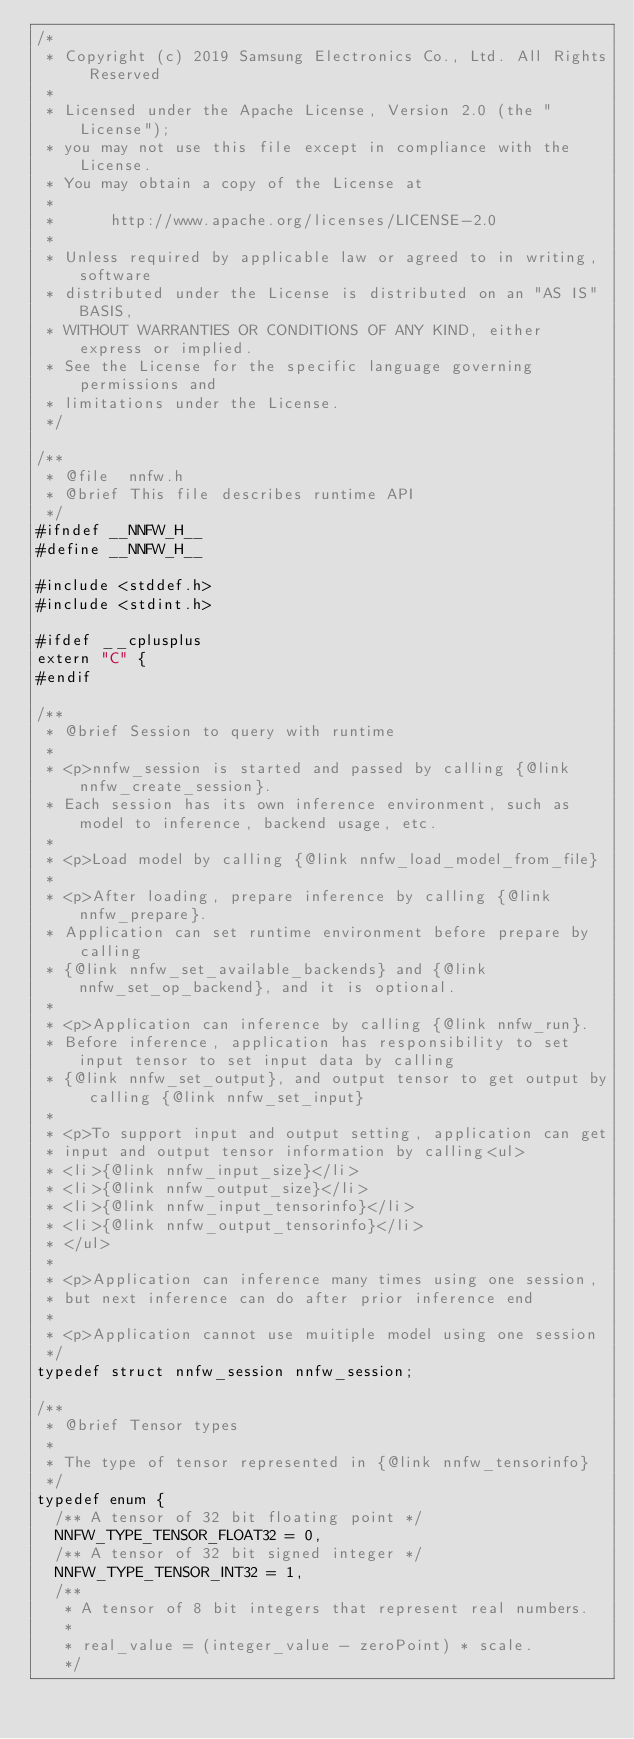<code> <loc_0><loc_0><loc_500><loc_500><_C_>/*
 * Copyright (c) 2019 Samsung Electronics Co., Ltd. All Rights Reserved
 *
 * Licensed under the Apache License, Version 2.0 (the "License");
 * you may not use this file except in compliance with the License.
 * You may obtain a copy of the License at
 *
 *      http://www.apache.org/licenses/LICENSE-2.0
 *
 * Unless required by applicable law or agreed to in writing, software
 * distributed under the License is distributed on an "AS IS" BASIS,
 * WITHOUT WARRANTIES OR CONDITIONS OF ANY KIND, either express or implied.
 * See the License for the specific language governing permissions and
 * limitations under the License.
 */

/**
 * @file  nnfw.h
 * @brief This file describes runtime API
 */
#ifndef __NNFW_H__
#define __NNFW_H__

#include <stddef.h>
#include <stdint.h>

#ifdef __cplusplus
extern "C" {
#endif

/**
 * @brief Session to query with runtime
 *
 * <p>nnfw_session is started and passed by calling {@link nnfw_create_session}.
 * Each session has its own inference environment, such as model to inference, backend usage, etc.
 *
 * <p>Load model by calling {@link nnfw_load_model_from_file}
 *
 * <p>After loading, prepare inference by calling {@link nnfw_prepare}.
 * Application can set runtime environment before prepare by calling
 * {@link nnfw_set_available_backends} and {@link nnfw_set_op_backend}, and it is optional.
 *
 * <p>Application can inference by calling {@link nnfw_run}.
 * Before inference, application has responsibility to set input tensor to set input data by calling
 * {@link nnfw_set_output}, and output tensor to get output by calling {@link nnfw_set_input}
 *
 * <p>To support input and output setting, application can get
 * input and output tensor information by calling<ul>
 * <li>{@link nnfw_input_size}</li>
 * <li>{@link nnfw_output_size}</li>
 * <li>{@link nnfw_input_tensorinfo}</li>
 * <li>{@link nnfw_output_tensorinfo}</li>
 * </ul>
 *
 * <p>Application can inference many times using one session,
 * but next inference can do after prior inference end
 *
 * <p>Application cannot use muitiple model using one session
 */
typedef struct nnfw_session nnfw_session;

/**
 * @brief Tensor types
 *
 * The type of tensor represented in {@link nnfw_tensorinfo}
 */
typedef enum {
  /** A tensor of 32 bit floating point */
  NNFW_TYPE_TENSOR_FLOAT32 = 0,
  /** A tensor of 32 bit signed integer */
  NNFW_TYPE_TENSOR_INT32 = 1,
  /**
   * A tensor of 8 bit integers that represent real numbers.
   *
   * real_value = (integer_value - zeroPoint) * scale.
   */</code> 